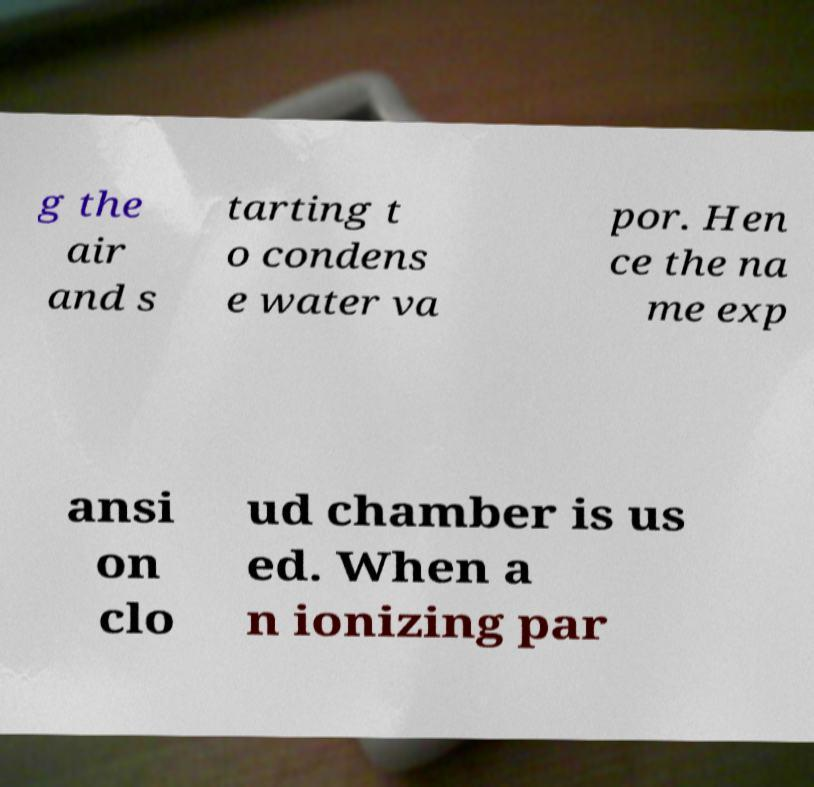Please read and relay the text visible in this image. What does it say? g the air and s tarting t o condens e water va por. Hen ce the na me exp ansi on clo ud chamber is us ed. When a n ionizing par 